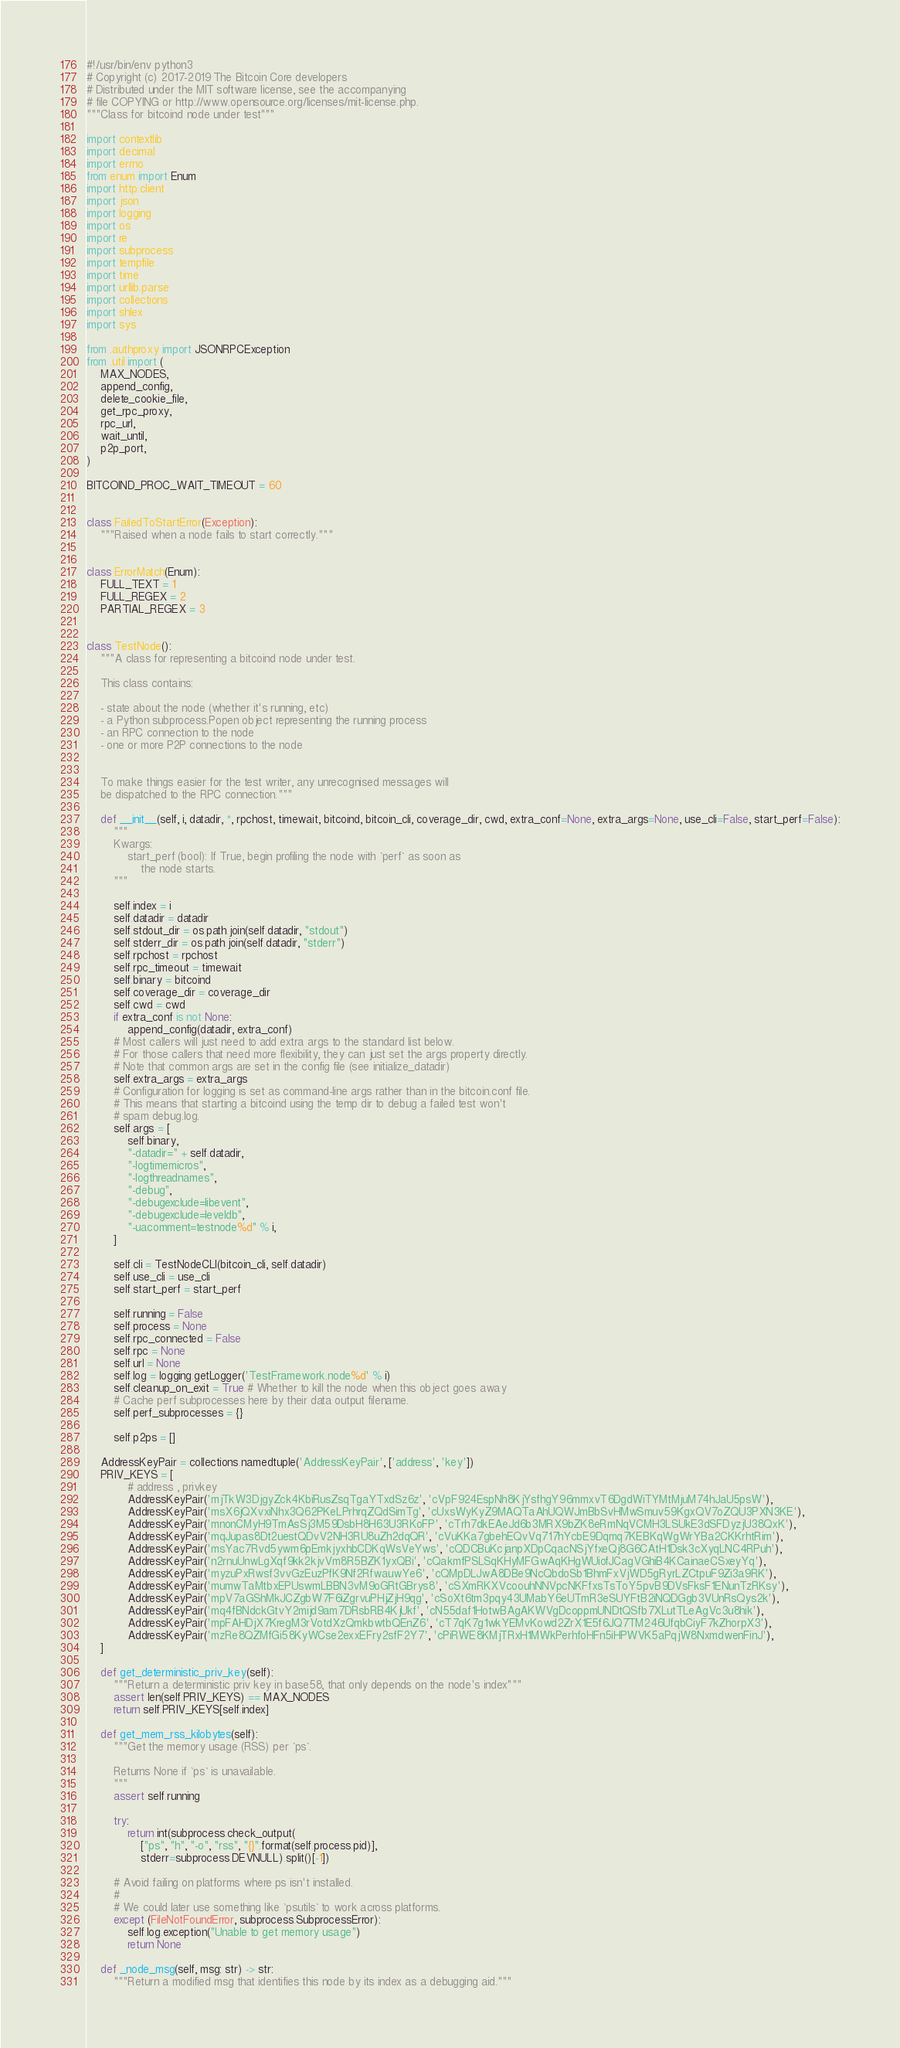Convert code to text. <code><loc_0><loc_0><loc_500><loc_500><_Python_>#!/usr/bin/env python3
# Copyright (c) 2017-2019 The Bitcoin Core developers
# Distributed under the MIT software license, see the accompanying
# file COPYING or http://www.opensource.org/licenses/mit-license.php.
"""Class for bitcoind node under test"""

import contextlib
import decimal
import errno
from enum import Enum
import http.client
import json
import logging
import os
import re
import subprocess
import tempfile
import time
import urllib.parse
import collections
import shlex
import sys

from .authproxy import JSONRPCException
from .util import (
    MAX_NODES,
    append_config,
    delete_cookie_file,
    get_rpc_proxy,
    rpc_url,
    wait_until,
    p2p_port,
)

BITCOIND_PROC_WAIT_TIMEOUT = 60


class FailedToStartError(Exception):
    """Raised when a node fails to start correctly."""


class ErrorMatch(Enum):
    FULL_TEXT = 1
    FULL_REGEX = 2
    PARTIAL_REGEX = 3


class TestNode():
    """A class for representing a bitcoind node under test.

    This class contains:

    - state about the node (whether it's running, etc)
    - a Python subprocess.Popen object representing the running process
    - an RPC connection to the node
    - one or more P2P connections to the node


    To make things easier for the test writer, any unrecognised messages will
    be dispatched to the RPC connection."""

    def __init__(self, i, datadir, *, rpchost, timewait, bitcoind, bitcoin_cli, coverage_dir, cwd, extra_conf=None, extra_args=None, use_cli=False, start_perf=False):
        """
        Kwargs:
            start_perf (bool): If True, begin profiling the node with `perf` as soon as
                the node starts.
        """

        self.index = i
        self.datadir = datadir
        self.stdout_dir = os.path.join(self.datadir, "stdout")
        self.stderr_dir = os.path.join(self.datadir, "stderr")
        self.rpchost = rpchost
        self.rpc_timeout = timewait
        self.binary = bitcoind
        self.coverage_dir = coverage_dir
        self.cwd = cwd
        if extra_conf is not None:
            append_config(datadir, extra_conf)
        # Most callers will just need to add extra args to the standard list below.
        # For those callers that need more flexibility, they can just set the args property directly.
        # Note that common args are set in the config file (see initialize_datadir)
        self.extra_args = extra_args
        # Configuration for logging is set as command-line args rather than in the bitcoin.conf file.
        # This means that starting a bitcoind using the temp dir to debug a failed test won't
        # spam debug.log.
        self.args = [
            self.binary,
            "-datadir=" + self.datadir,
            "-logtimemicros",
            "-logthreadnames",
            "-debug",
            "-debugexclude=libevent",
            "-debugexclude=leveldb",
            "-uacomment=testnode%d" % i,
        ]

        self.cli = TestNodeCLI(bitcoin_cli, self.datadir)
        self.use_cli = use_cli
        self.start_perf = start_perf

        self.running = False
        self.process = None
        self.rpc_connected = False
        self.rpc = None
        self.url = None
        self.log = logging.getLogger('TestFramework.node%d' % i)
        self.cleanup_on_exit = True # Whether to kill the node when this object goes away
        # Cache perf subprocesses here by their data output filename.
        self.perf_subprocesses = {}

        self.p2ps = []

    AddressKeyPair = collections.namedtuple('AddressKeyPair', ['address', 'key'])
    PRIV_KEYS = [
            # address , privkey
            AddressKeyPair('mjTkW3DjgyZck4KbiRusZsqTgaYTxdSz6z', 'cVpF924EspNh8KjYsfhgY96mmxvT6DgdWiTYMtMjuM74hJaU5psW'),
            AddressKeyPair('msX6jQXvxiNhx3Q62PKeLPrhrqZQdSimTg', 'cUxsWyKyZ9MAQTaAhUQWJmBbSvHMwSmuv59KgxQV7oZQU3PXN3KE'),
            AddressKeyPair('mnonCMyH9TmAsSj3M59DsbH8H63U3RKoFP', 'cTrh7dkEAeJd6b3MRX9bZK8eRmNqVCMH3LSUkE3dSFDyzjU38QxK'),
            AddressKeyPair('mqJupas8Dt2uestQDvV2NH3RU8uZh2dqQR', 'cVuKKa7gbehEQvVq717hYcbE9Dqmq7KEBKqWgWrYBa2CKKrhtRim'),
            AddressKeyPair('msYac7Rvd5ywm6pEmkjyxhbCDKqWsVeYws', 'cQDCBuKcjanpXDpCqacNSjYfxeQj8G6CAtH1Dsk3cXyqLNC4RPuh'),
            AddressKeyPair('n2rnuUnwLgXqf9kk2kjvVm8R5BZK1yxQBi', 'cQakmfPSLSqKHyMFGwAqKHgWUiofJCagVGhiB4KCainaeCSxeyYq'),
            AddressKeyPair('myzuPxRwsf3vvGzEuzPfK9Nf2RfwauwYe6', 'cQMpDLJwA8DBe9NcQbdoSb1BhmFxVjWD5gRyrLZCtpuF9Zi3a9RK'),
            AddressKeyPair('mumwTaMtbxEPUswmLBBN3vM9oGRtGBrys8', 'cSXmRKXVcoouhNNVpcNKFfxsTsToY5pvB9DVsFksF1ENunTzRKsy'),
            AddressKeyPair('mpV7aGShMkJCZgbW7F6iZgrvuPHjZjH9qg', 'cSoXt6tm3pqy43UMabY6eUTmR3eSUYFtB2iNQDGgb3VUnRsQys2k'),
            AddressKeyPair('mq4fBNdckGtvY2mijd9am7DRsbRB4KjUkf', 'cN55daf1HotwBAgAKWVgDcoppmUNDtQSfb7XLutTLeAgVc3u8hik'),
            AddressKeyPair('mpFAHDjX7KregM3rVotdXzQmkbwtbQEnZ6', 'cT7qK7g1wkYEMvKowd2ZrX1E5f6JQ7TM246UfqbCiyF7kZhorpX3'),
            AddressKeyPair('mzRe8QZMfGi58KyWCse2exxEFry2sfF2Y7', 'cPiRWE8KMjTRxH1MWkPerhfoHFn5iHPWVK5aPqjW8NxmdwenFinJ'),
    ]

    def get_deterministic_priv_key(self):
        """Return a deterministic priv key in base58, that only depends on the node's index"""
        assert len(self.PRIV_KEYS) == MAX_NODES
        return self.PRIV_KEYS[self.index]

    def get_mem_rss_kilobytes(self):
        """Get the memory usage (RSS) per `ps`.

        Returns None if `ps` is unavailable.
        """
        assert self.running

        try:
            return int(subprocess.check_output(
                ["ps", "h", "-o", "rss", "{}".format(self.process.pid)],
                stderr=subprocess.DEVNULL).split()[-1])

        # Avoid failing on platforms where ps isn't installed.
        #
        # We could later use something like `psutils` to work across platforms.
        except (FileNotFoundError, subprocess.SubprocessError):
            self.log.exception("Unable to get memory usage")
            return None

    def _node_msg(self, msg: str) -> str:
        """Return a modified msg that identifies this node by its index as a debugging aid."""</code> 